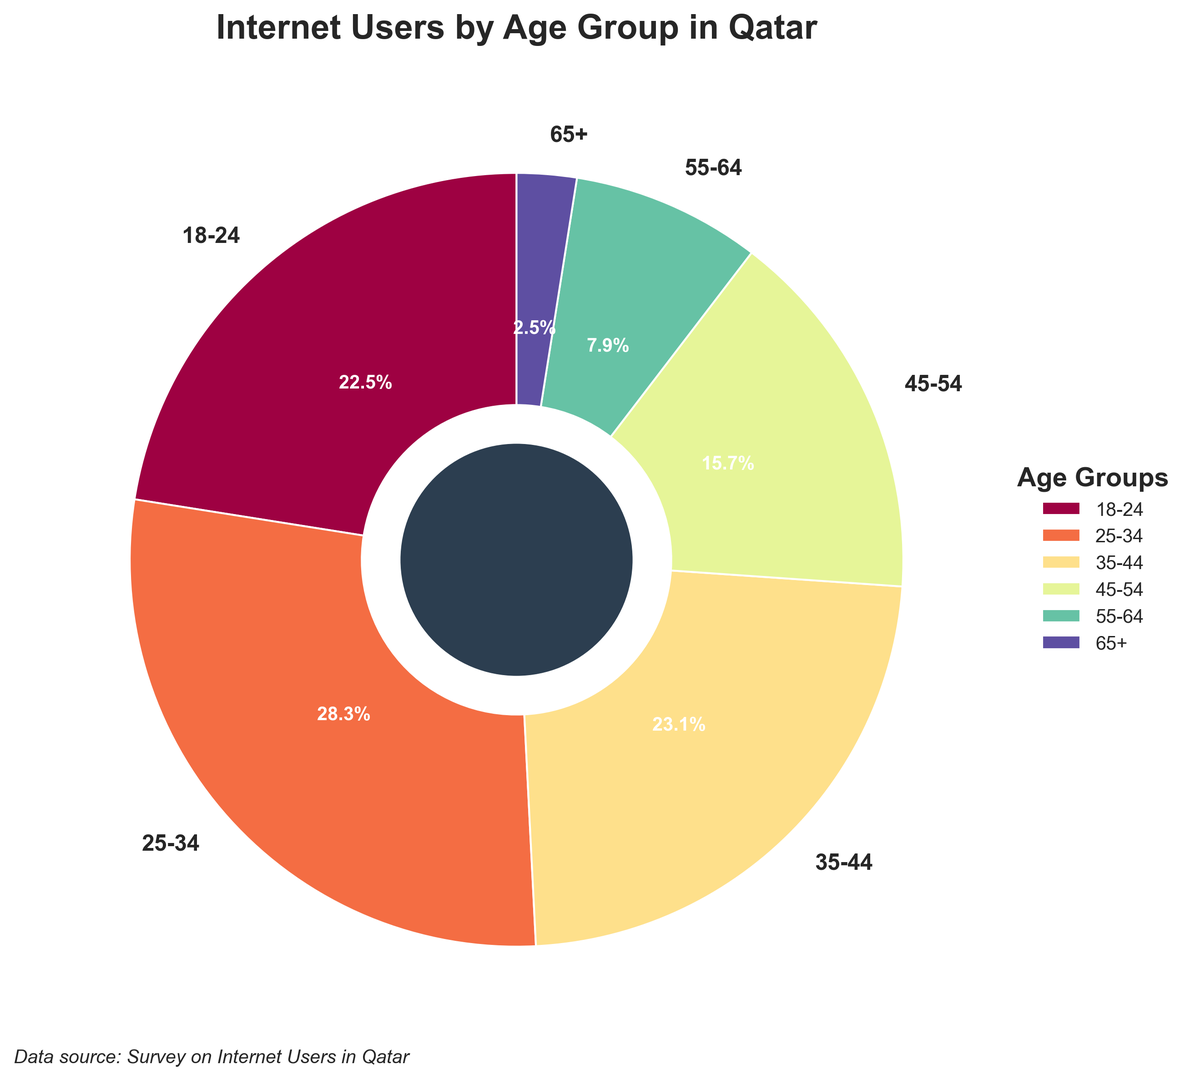What percentage of internet users in Qatar are aged 25-34? The pie chart lists the percentages of internet users by age group. The segment labeled "25-34" shows 28.3%.
Answer: 28.3% Which age group has the lowest percentage of internet users in Qatar? The age group segments are labeled with their percentages. The segment with the smallest percentage is "65+" with 2.5%.
Answer: 65+ How many age groups have more than 20% of internet users in Qatar? Check the percentages for each age group and count those above 20%. Both "18-24" (22.5%) and "25-34" (28.3%) and "35-44" (23.1%) are above 20%.
Answer: 3 What is the combined percentage of internet users in Qatar aged 35-54? Add the percentages for the "35-44" and "45-54" age groups. 23.1% + 15.7% = 38.8%.
Answer: 38.8% Is there a significant difference between the percentages of internet users aged 18-24 and 35-44 in Qatar? The percentages are 22.5% for "18-24" and 23.1% for "35-44". The difference is 23.1% - 22.5% = 0.6%, which is relatively small.
Answer: No Which age group has a higher percentage of internet users: 55-64 or 45-54 in Qatar? The segment for "45-54" has 15.7%, while the segment for "55-64" has 7.9%. 15.7% is higher than 7.9%.
Answer: 45-54 What is the total percentage of internet users in Qatar who are aged 18-34? Add the percentages of the "18-24" and "25-34" age groups. 22.5% + 28.3% = 50.8%.
Answer: 50.8% What are the visual traits used to distinguish different age groups in the pie chart? Different segments of the pie chart are distinguished by unique colors, and labels next to each segment indicate the age group and percentage.
Answer: Colors and labels What percentage more are 25-34 year-olds compared to 55-64 year-olds in terms of internet usage in Qatar? Subtract the percentage of "55-64" from "25-34". 28.3% - 7.9% = 20.4%.
Answer: 20.4% Which age group represents less than 10% of internet users in Qatar? Both "55-64" (7.9%) and "65+" (2.5%) segments represent less than 10%.
Answer: 55-64 and 65+ 